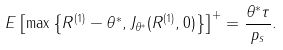<formula> <loc_0><loc_0><loc_500><loc_500>E \left [ \max \left \{ R ^ { ( 1 ) } - \theta ^ { * } , J _ { \theta ^ { * } } ( R ^ { ( 1 ) } , 0 ) \right \} \right ] ^ { + } = \frac { \theta ^ { * } \tau } { p _ { s } } .</formula> 